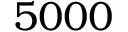Convert formula to latex. <formula><loc_0><loc_0><loc_500><loc_500>5 0 0 0</formula> 